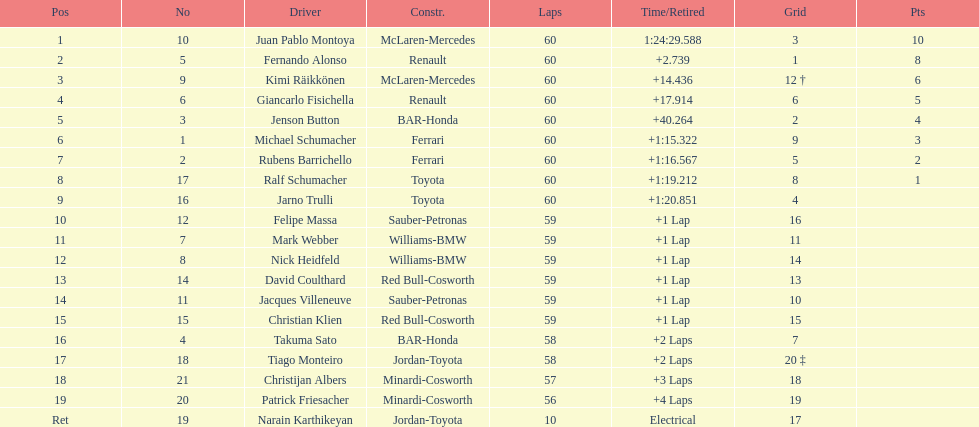What is the number of toyota's on the list? 4. 